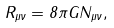Convert formula to latex. <formula><loc_0><loc_0><loc_500><loc_500>R _ { \mu \nu } = 8 \pi G N _ { \mu \nu } ,</formula> 